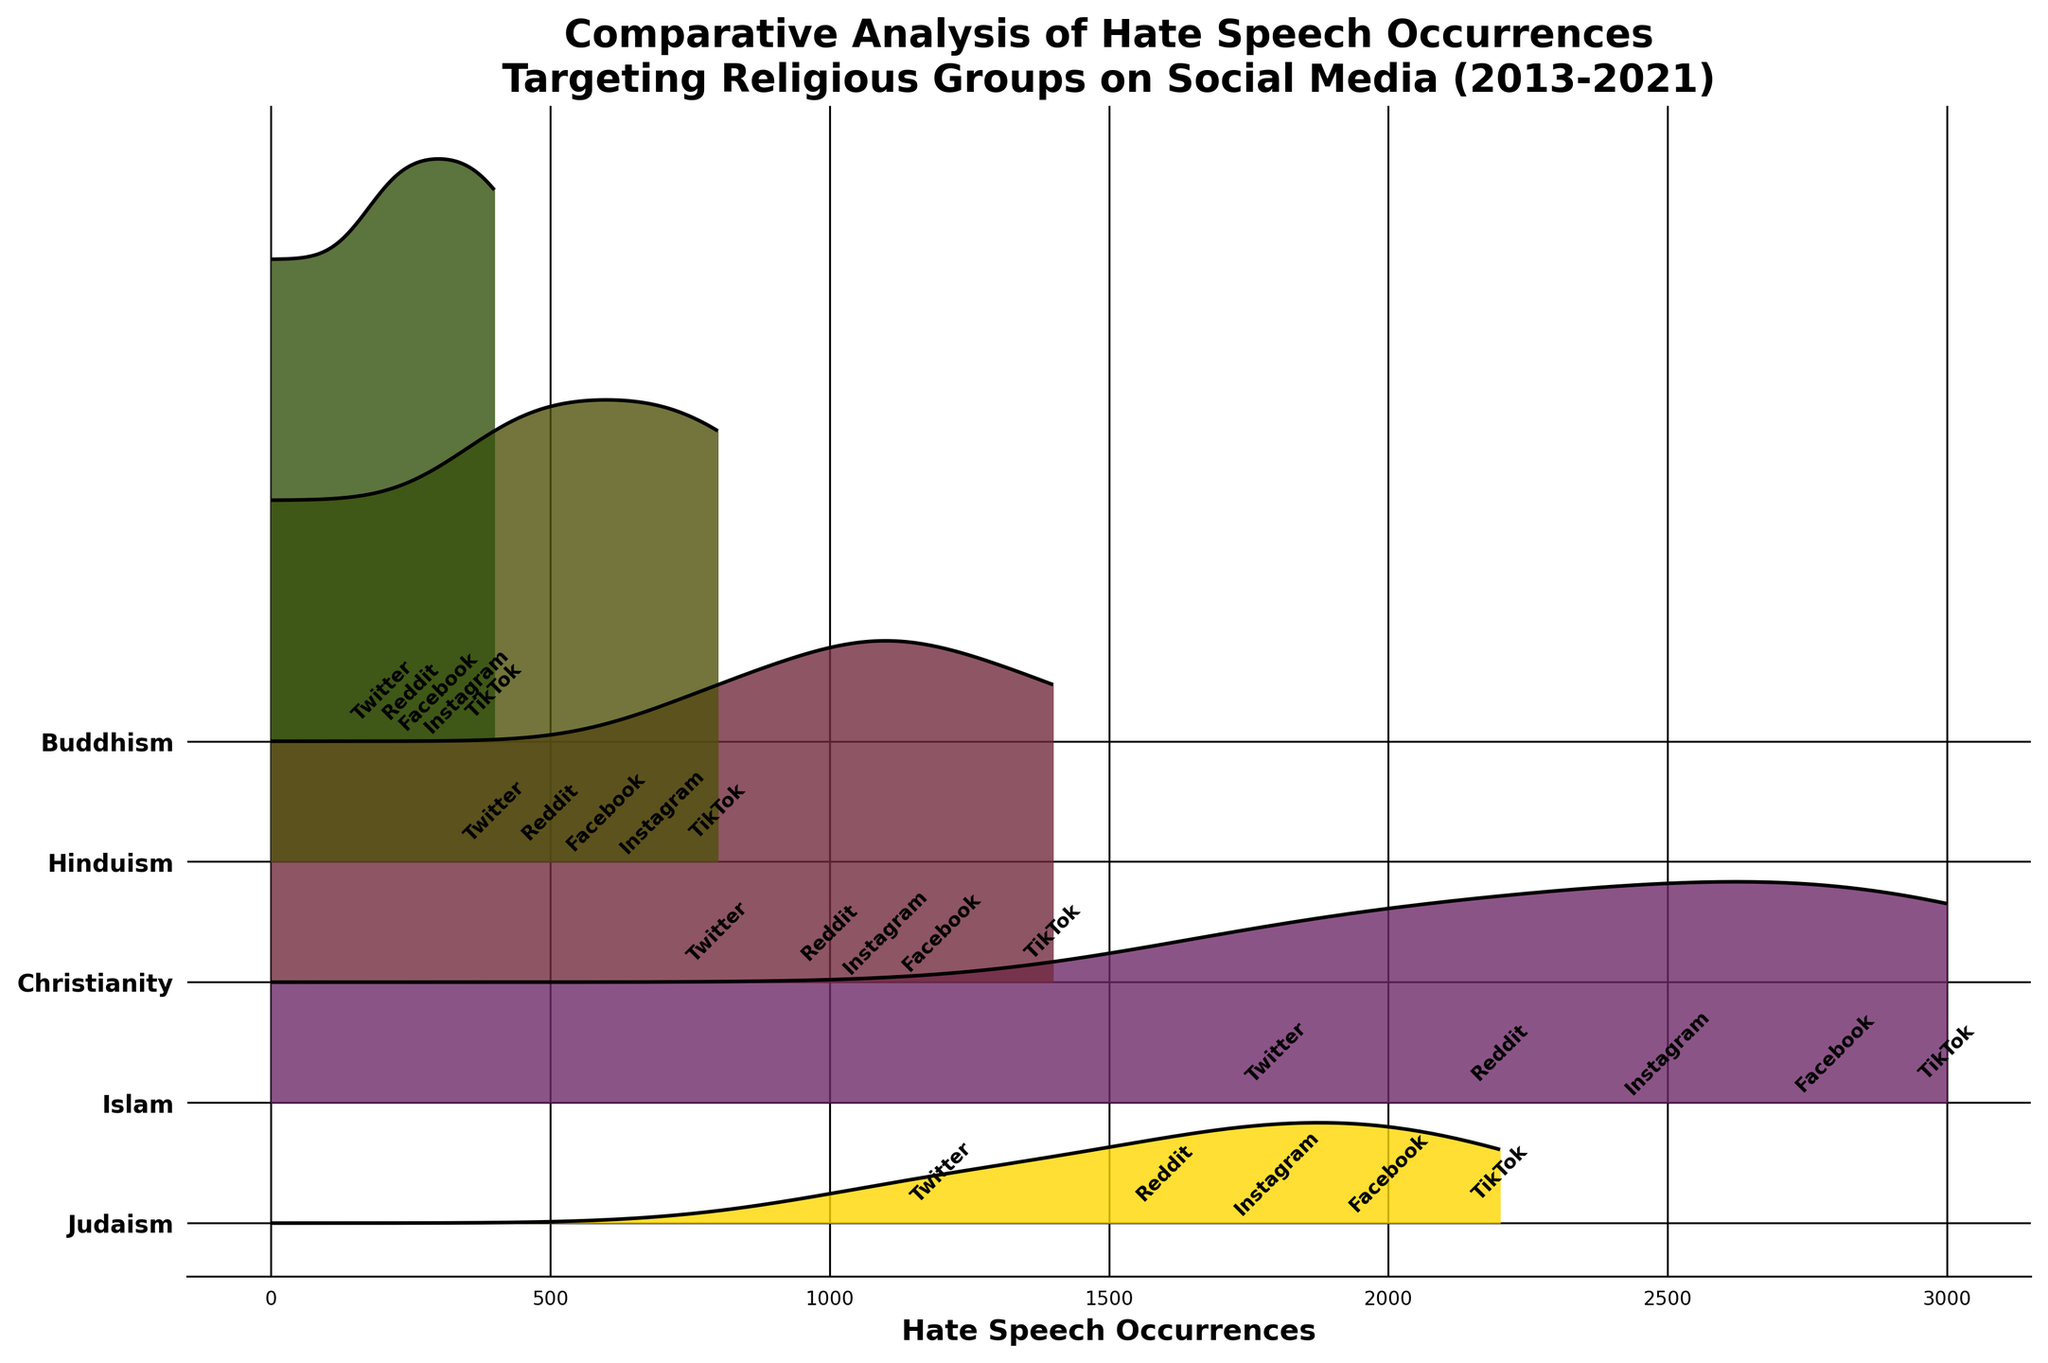What is the title of the plot? The title is located at the top of the plot, indicating the overall theme. It reads "Comparative Analysis of Hate Speech Occurrences Targeting Religious Groups on Social Media (2013-2021)."
Answer: Comparative Analysis of Hate Speech Occurrences Targeting Religious Groups on Social Media (2013-2021) What are the religions compared in the plot? The religions are listed on the y-axis, each associated with a different horizontal level in the ridgeline plot. The religions compared are Judaism, Islam, Christianity, Hinduism, and Buddhism.
Answer: Judaism, Islam, Christianity, Hinduism, Buddhism In which year did Islam see the highest occurrence of hate speech? Identify the peak of the ridgeline representing Islam. The highest occurrence in that ridge corresponds with the year 2021 on TikTok, reaching approximately 3000 hate speech occurrences.
Answer: 2021 Which social media platform shows the highest hate speech occurrences for Judaism? Look at the different ridgelines and their peaks for Judaism. The highest peak is around 2200 occurrences on TikTok in 2021.
Answer: TikTok How does the hate speech occurrence for Christianity on Instagram compare to Twitter? Find the ridgelines representing Christianity and compare the heights for Instagram and Twitter. On Instagram in 2019, the peak is about 1100 occurrences, while on Twitter in 2013, the peak is about 800 occurrences.
Answer: Instagram has more occurrences than Twitter What is the trend of hate speech occurrences for Hinduism over the years? Examine the height of the ridged areas for Hinduism across the years. The heights increase from 400 in 2013 (Twitter), to 600 in 2015 (Facebook), 500 in 2017 (Reddit), 700 in 2019 (Instagram), and 800 in 2021 (TikTok). This indicates a general upward trend.
Answer: Upward trend What was the hate speech level for Buddhism on Reddit in 2017? Locate the ridgeline for Buddhism and find the peak corresponding to Reddit in 2017. Look for the numerical label around the peak, which is approximately 250 occurrences.
Answer: 250 Which religion experienced the least hate speech occurrences in 2015? Compare the height of all ridgelines in 2015. Buddhism has the smallest peak with around 300 occurrences on Facebook in 2015.
Answer: Buddhism On which social media platform did hate speech occurrences peak for Christianity? Examine the peaks of the ridgelines for Christianity and identify the highest one. The peak occurs on TikTok in 2021, with about 1400 occurrences.
Answer: TikTok 